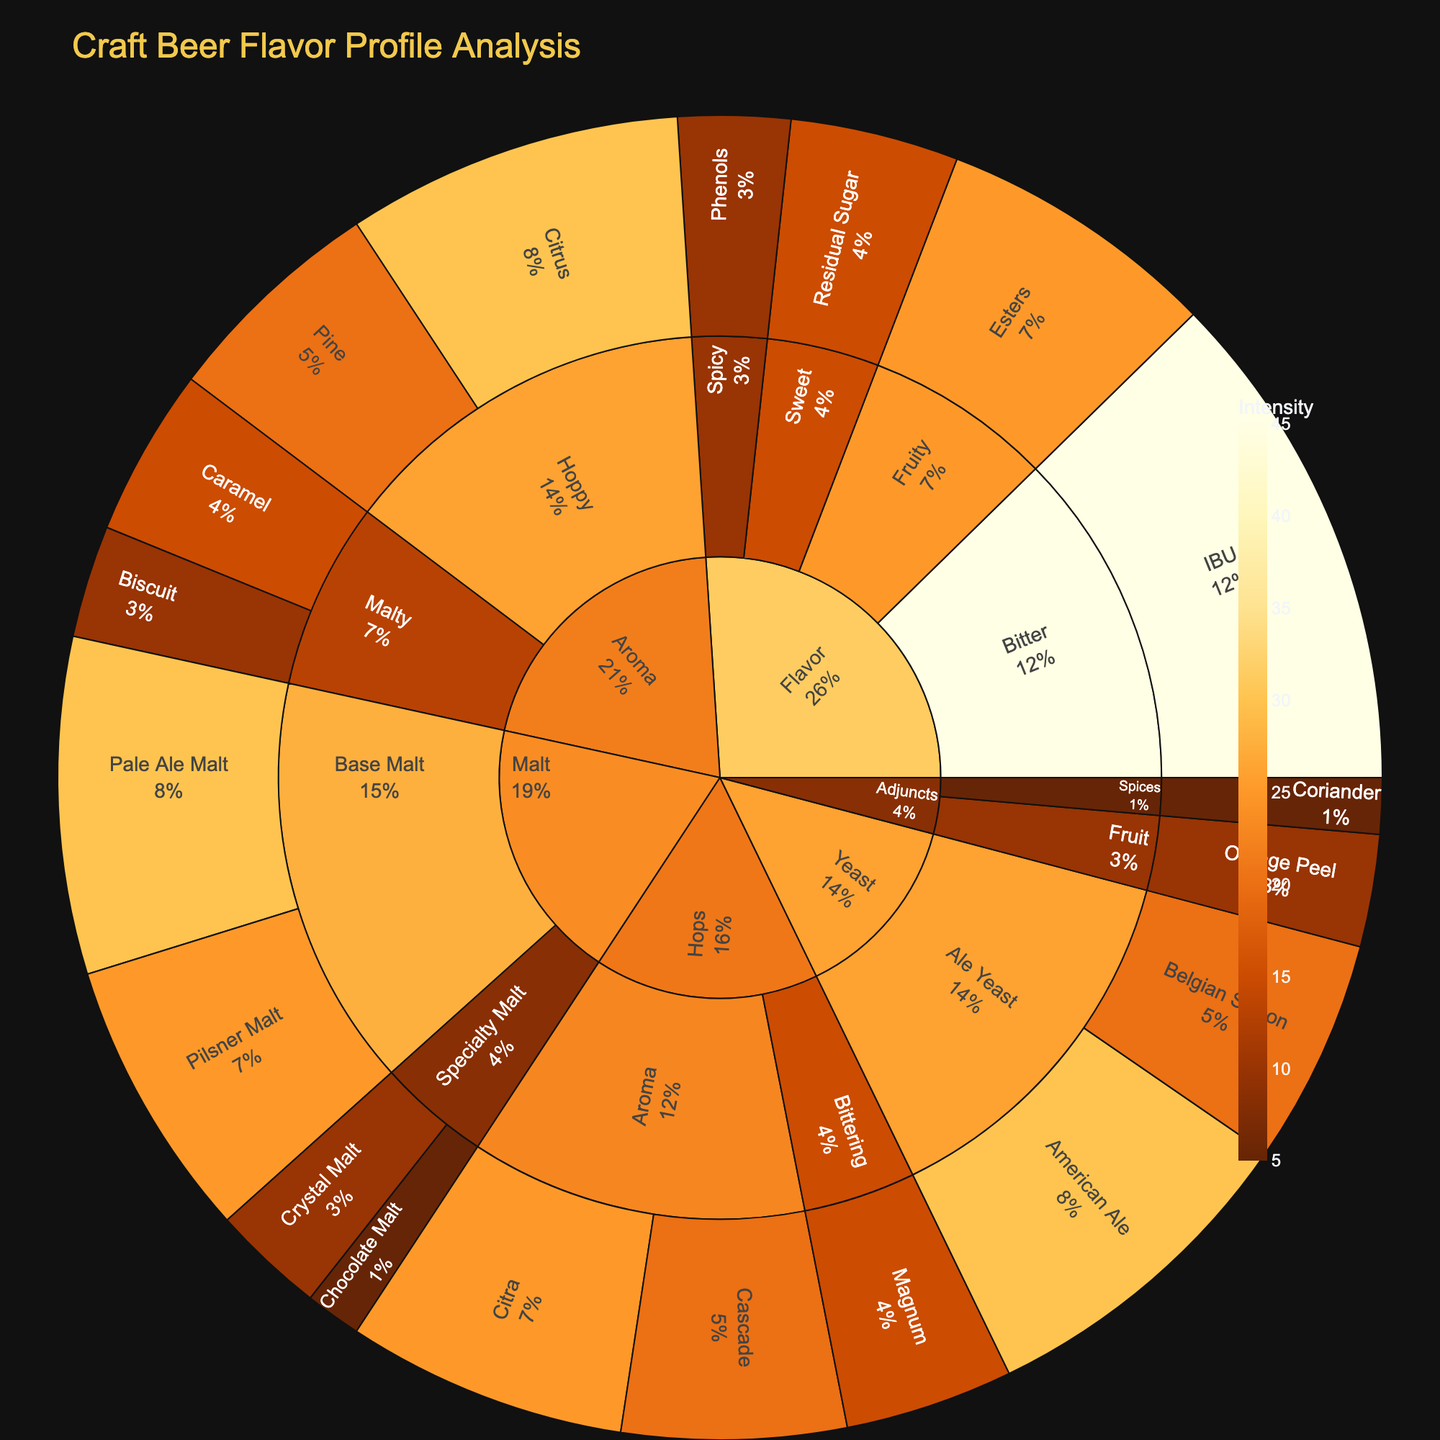What is the title of the sunburst plot? The title is displayed at the top of the figure. It reads "Craft Beer Flavor Profile Analysis".
Answer: Craft Beer Flavor Profile Analysis What is the category with the highest value? Observe the outermost labels and their percentage share to find the category with the highest share. "Yeast" has elements with the highest aggregate values totaling 50 (American Ale: 30 + Belgian Saison: 20).
Answer: Yeast Which element has the highest intensity under the Aroma category? Look under the 'Aroma' category and compare the values of its elements. "Citrus" has the highest value at 30.
Answer: Citrus What is the combined value for the Aroma category? Add up values for all elements under 'Aroma': Citrus (30) + Pine (20) + Caramel (15) + Biscuit (10) = 75.
Answer: 75 Which subcategory has the lowest value within the Malt category? Compare values of each subcategory under 'Malt'. 'Chocolate Malt' under 'Specialty Malt' has the lowest value of 5.
Answer: Specialty Malt (Chocolate Malt) What is the total value for all the elements under the Hops category? Add values of all elements under 'Hops': Magnum (15) + Cascade (20) + Citra (25) = 60.
Answer: 60 How does the value of American Ale compare with that of Pale Ale Malt? American Ale (30) is compared with Pale Ale Malt (30). Both have the same value.
Answer: Equal Which category has more value: Adjuncts or Flavor? Sum values for elements under both categories: 
Adjuncts: Coriander (5) + Orange Peel (10) = 15 
Flavor: IBU (45) + Residual Sugar (15) + Esters (25) + Phenols (10) = 95. Flavor has more value.
Answer: Flavor Between the subcategories of Hops, which has the larger aggregate value? Sum values for each 'Hops' subcategory: Bittering: Magnum (15); Aroma: Cascade (20) + Citra (25) = 45. Aroma has a larger value.
Answer: Aroma What percentage does the Pale Ale Malt contribute within the Malt category? Total value for 'Malt' category: Pale Ale Malt (30) + Pilsner Malt (25) + Crystal Malt (10) + Chocolate Malt (5) = 70. Contribution of Pale Ale Malt: (30/70) * 100 ≈ 42.9%.
Answer: 42.9% 